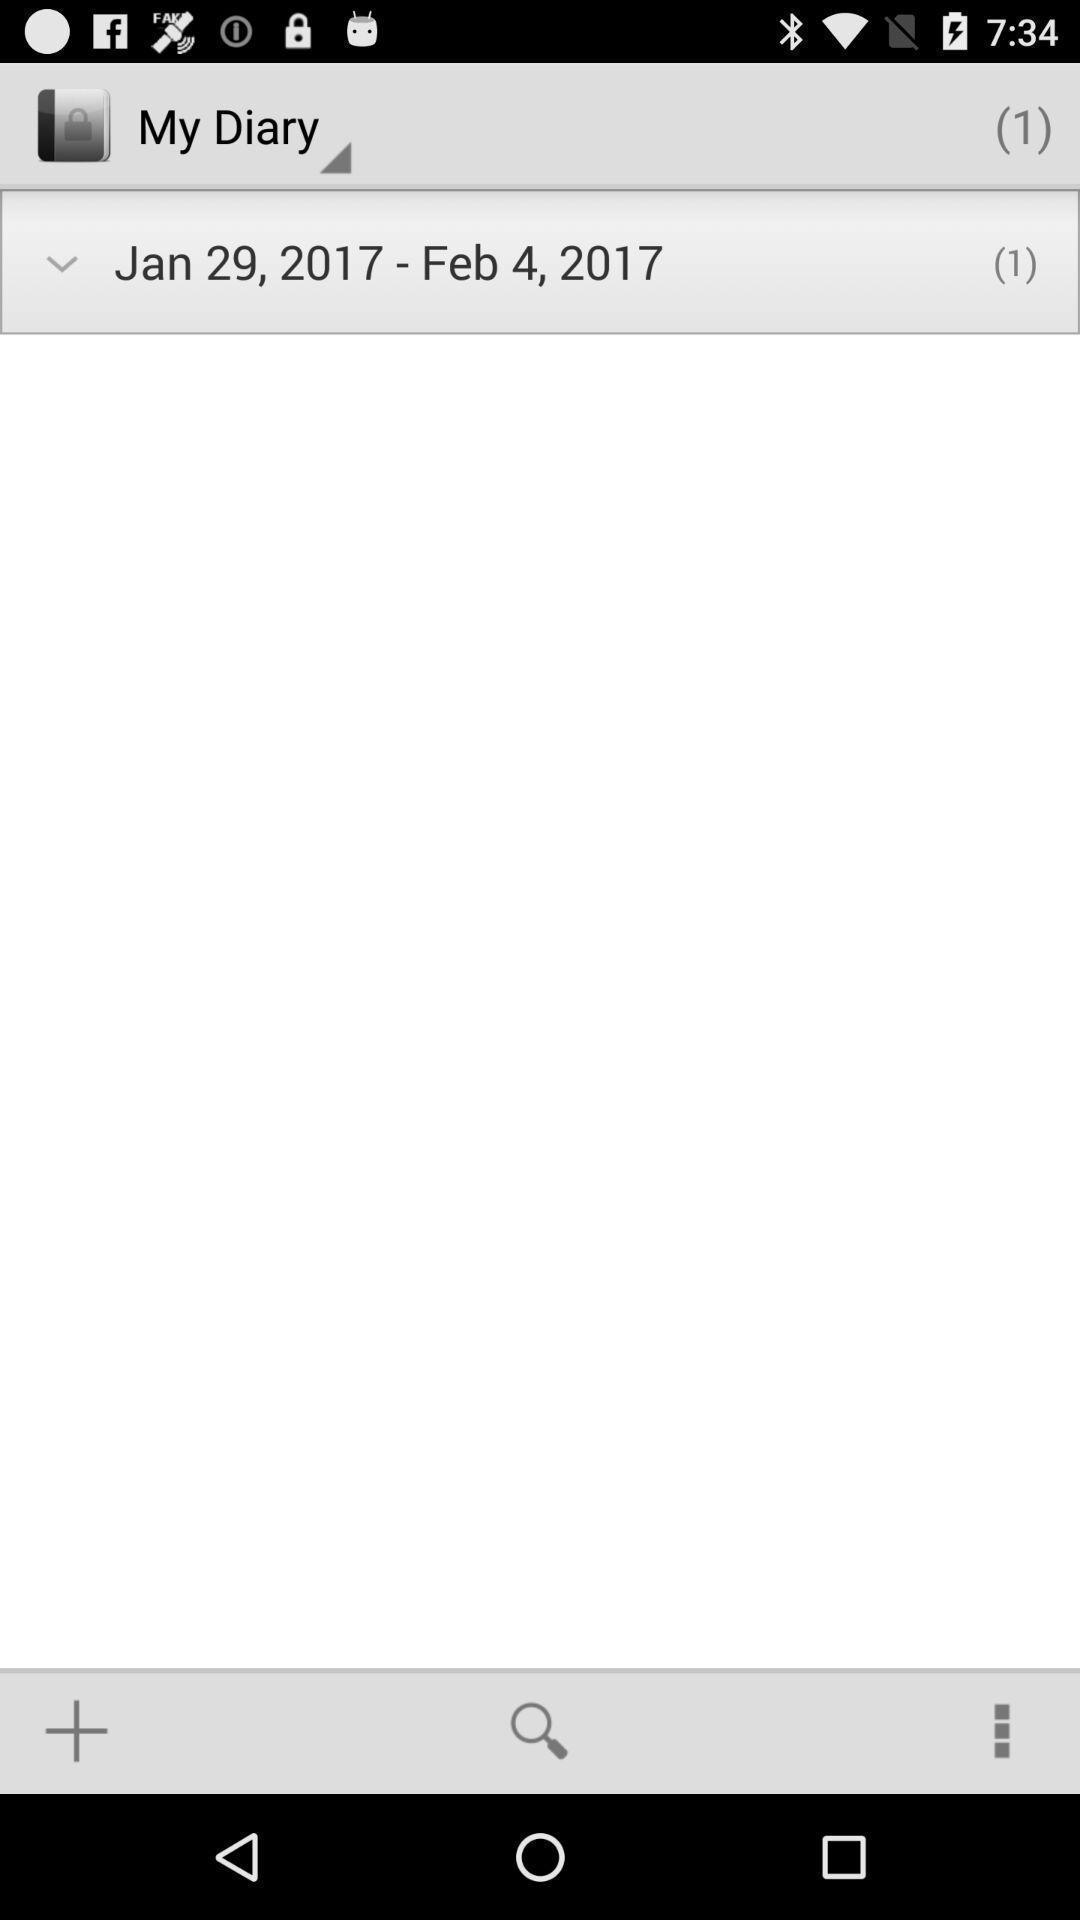What details can you identify in this image? Screen page of a diary application. 